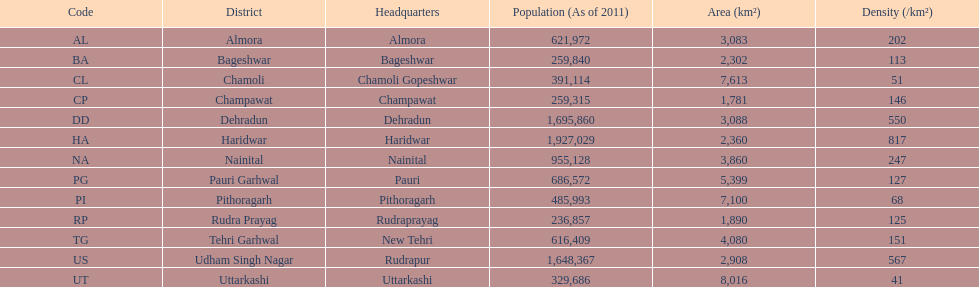How many districts have an area exceeding 5000? 4. 